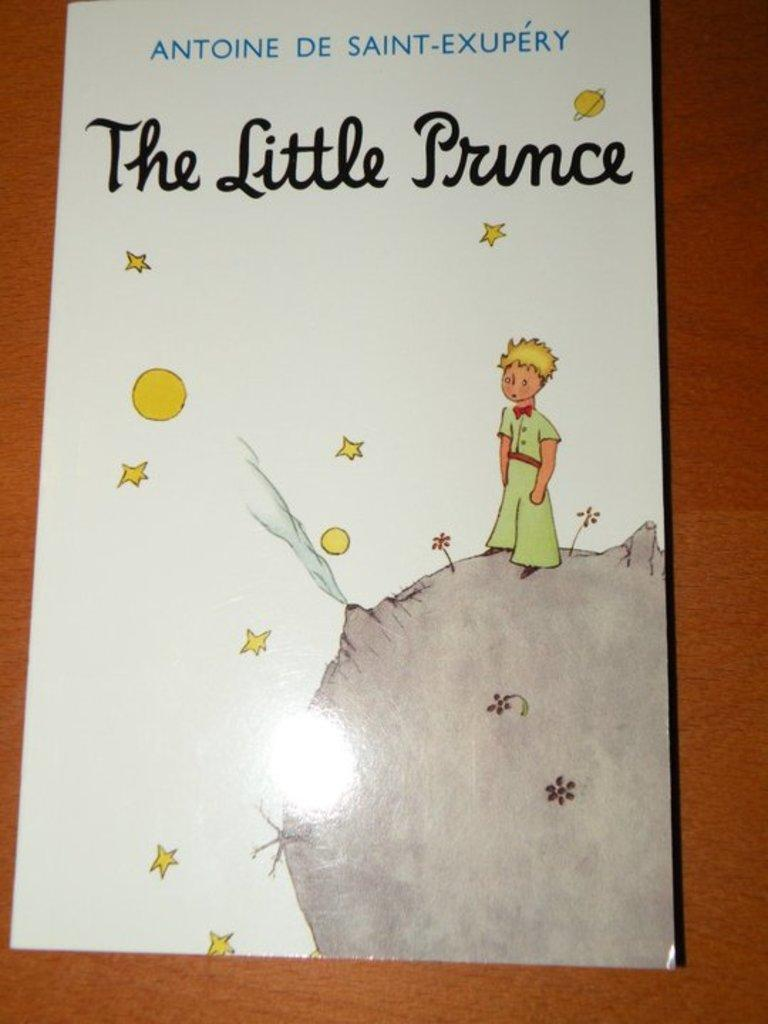<image>
Render a clear and concise summary of the photo. A story book titled "The Little Prince" on a table. 